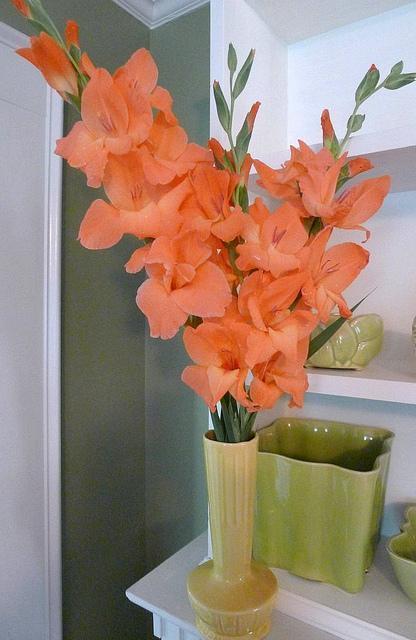How many vases can be seen?
Give a very brief answer. 3. 